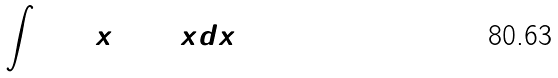<formula> <loc_0><loc_0><loc_500><loc_500>\int \sin ^ { 2 } x \cos ^ { 2 } x d x</formula> 